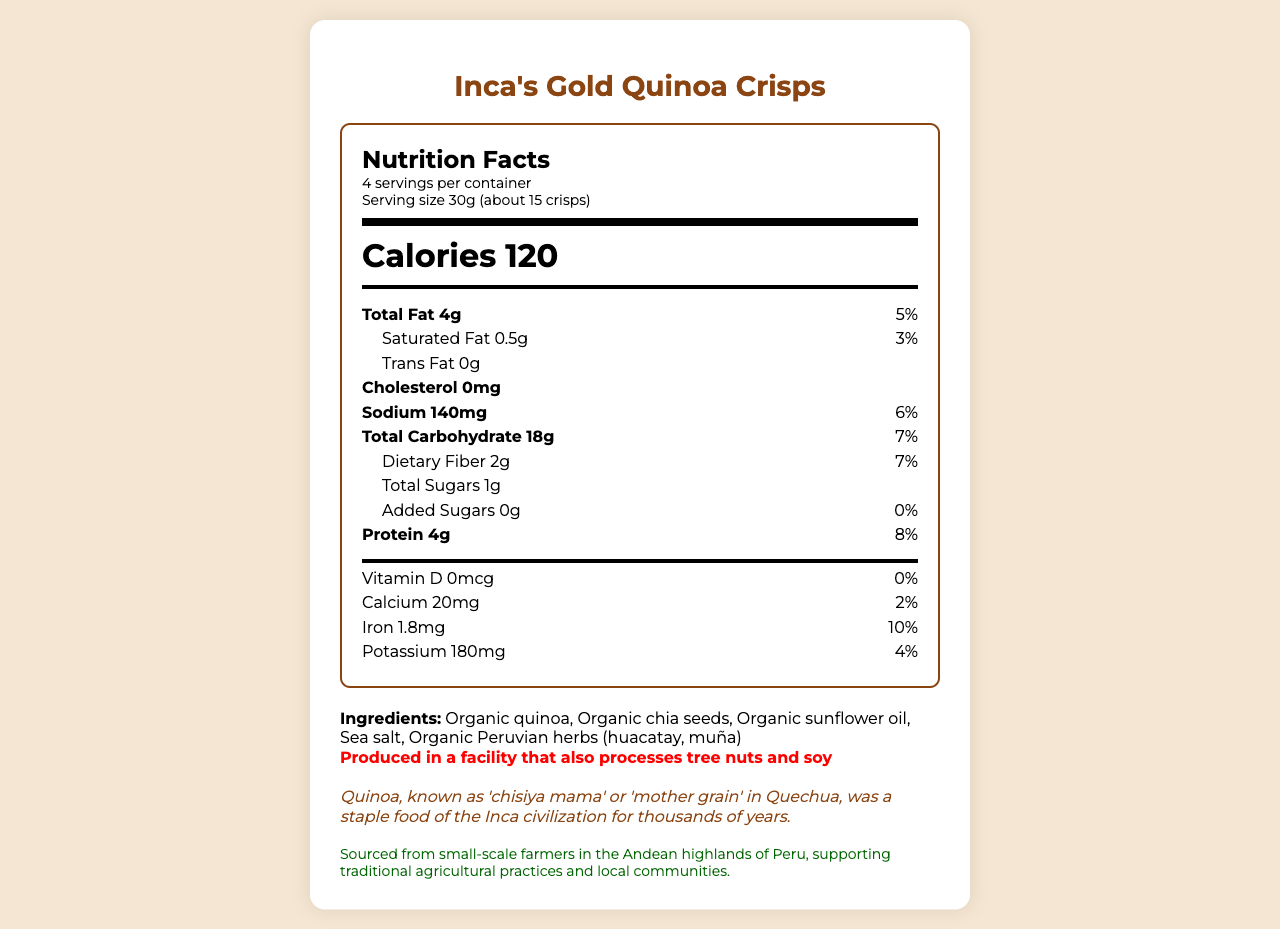what is the serving size for Inca's Gold Quinoa Crisps? The serving size is clearly stated in the document as 30g, which is approximately 15 crisps.
Answer: 30g (about 15 crisps) how many total servings are in the container? The document specifies that there are 4 servings per container.
Answer: 4 how much protein is in one serving of crisps? Under the nutrition label, it indicates that one serving of the crisps contains 4g of protein.
Answer: 4g what is the daily value percentage of iron per serving? The nutrition label lists the daily value percentage for iron as 10%.
Answer: 10% which ingredient is listed first in the ingredients section? The first ingredient listed is 'Organic quinoa'.
Answer: Organic quinoa how many calories are there per serving? The document states that there are 120 calories per serving.
Answer: 120 how much dietary fiber does one serving contain? The dietary fiber content per serving is listed as 2g in the nutrition label.
Answer: 2g what is the cultural significance of quinoa in the Incan civilization? In the 'ancient incan heritage' section, it mentions that quinoa was believed to be sacred and was offered to the Inca Sun God, Inti, in religious ceremonies.
Answer: Believed to be sacred, quinoa was offered to the Inca Sun God, Inti, during religious ceremonies. what is the amount of total carbohydrate in one serving? A. 10g B. 18g C. 25g The document states that one serving contains 18g of total carbohydrate.
Answer: B which of the following is not an ingredient in Inca's Gold Quinoa Crisps? A. Organic chia seeds B. Organic sunflower oil C. High fructose corn syrup High fructose corn syrup is not listed among the ingredients; the other two are mentioned.
Answer: C is there any trans fat in this product? The nutrition label clearly indicates that there is 0g of trans fat per serving.
Answer: No describe the main idea of this nutrition facts label The document serves to inform consumers about the nutritional details of the product, its historical significance, and the ethical sourcing of its ingredients.
Answer: This document provides the nutritional information for Inca's Gold Quinoa Crisps, including serving size, calorie content, and nutrient breakdown such as protein and fiber. It also highlights the product's ingredients, the ancient Incan heritage of quinoa, and the product's sustainability note. how many added sugars are there in one serving of crisps? The nutrition label lists the amount of added sugars per serving as 0g.
Answer: 0g how much calcium is in one serving? The nutrition label specifies that one serving contains 20mg of calcium.
Answer: 20mg where is the quinoa sourced from? The document mentions that the quinoa is sourced from small-scale farmers in the Andean highlands of Peru but does not specify any exact location.
Answer: Cannot be determined what was the relevant experience for participants of Ruta Quetzal BBVA 2009 in relation to quinoa? The 'ruta_quetzal_connection' section mentions that participants visited Cusco and learned about traditional Andean crops, including quinoa.
Answer: Participants visited Cusco, the ancient capital of the Inca Empire, and learned about traditional Andean crops including quinoa. describe one way in which the heritage of the Inca civilization is connected to this product The 'ancient_incan_heritage' section describes quinoa's significance as a staple food known as 'chisiya mama' and essential for the Incas due to its high nutritional value.
Answer: Quinoa was known as 'chisiya mama' or 'mother grain' and was a staple food for the Incas. Recognized for its complete protein profile, it supported their sustenance in the high Andes. 